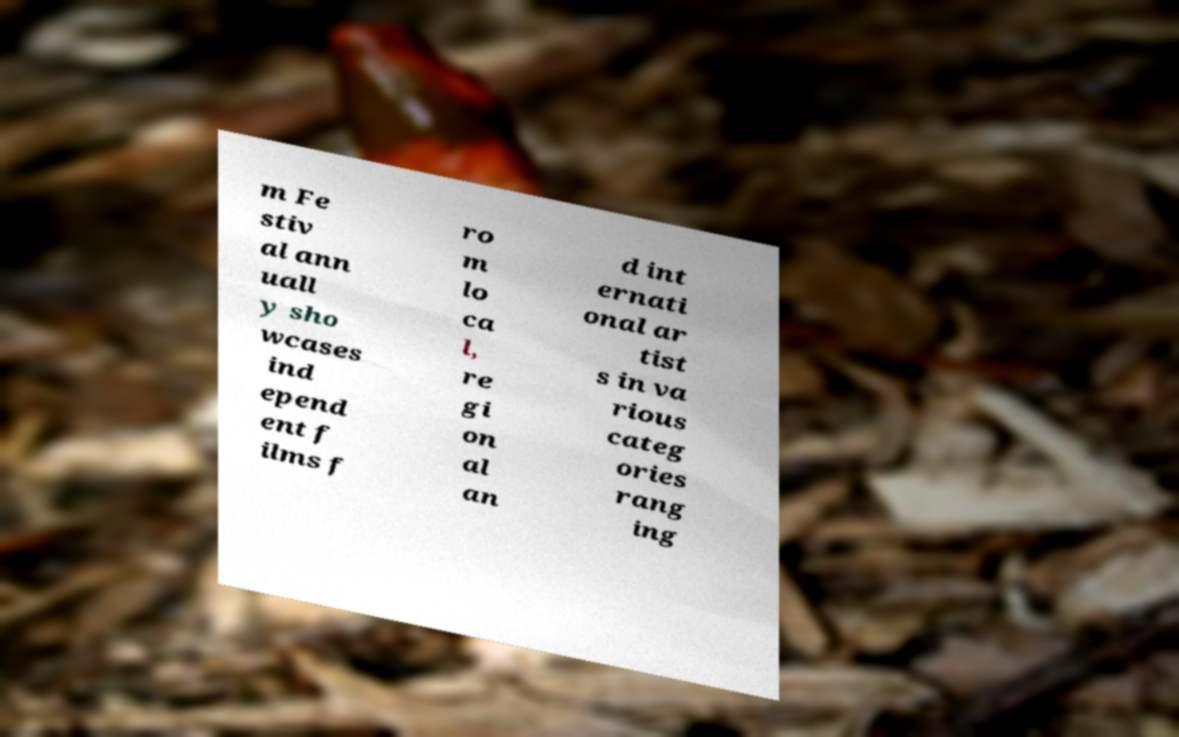Could you extract and type out the text from this image? m Fe stiv al ann uall y sho wcases ind epend ent f ilms f ro m lo ca l, re gi on al an d int ernati onal ar tist s in va rious categ ories rang ing 